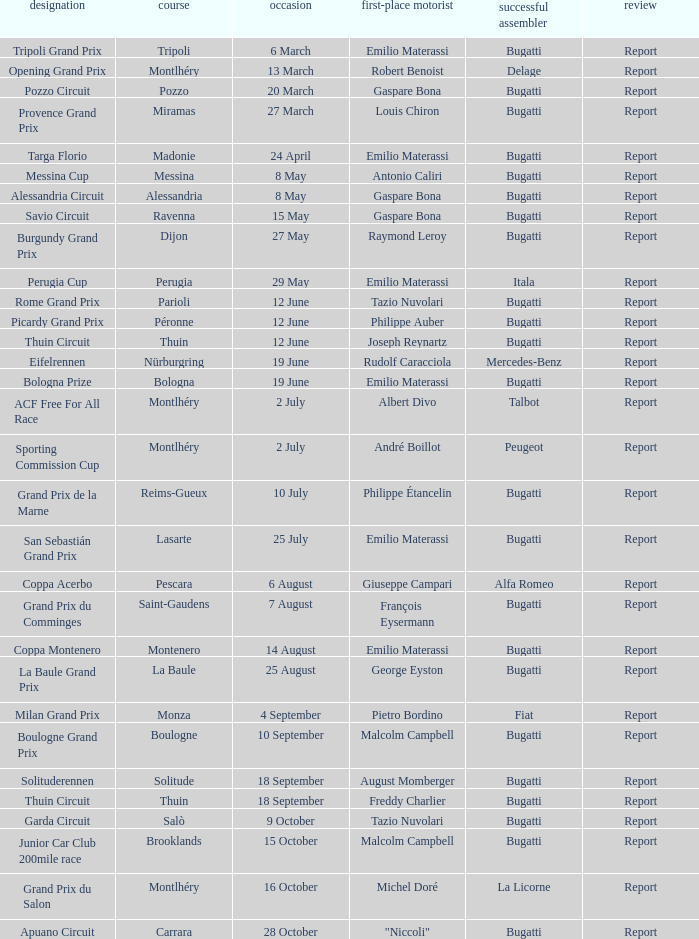Who was the winning constructor of the Grand Prix Du Salon ? La Licorne. 